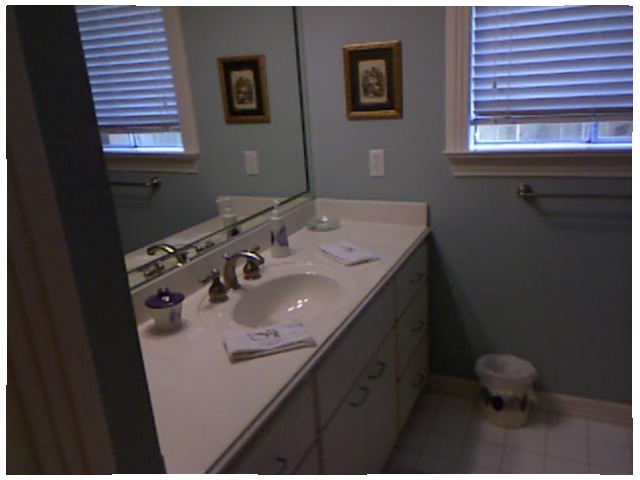<image>
Is there a soap to the right of the sink? Yes. From this viewpoint, the soap is positioned to the right side relative to the sink. Is there a bag in the can? Yes. The bag is contained within or inside the can, showing a containment relationship. Is there a towel in the sink? No. The towel is not contained within the sink. These objects have a different spatial relationship. 